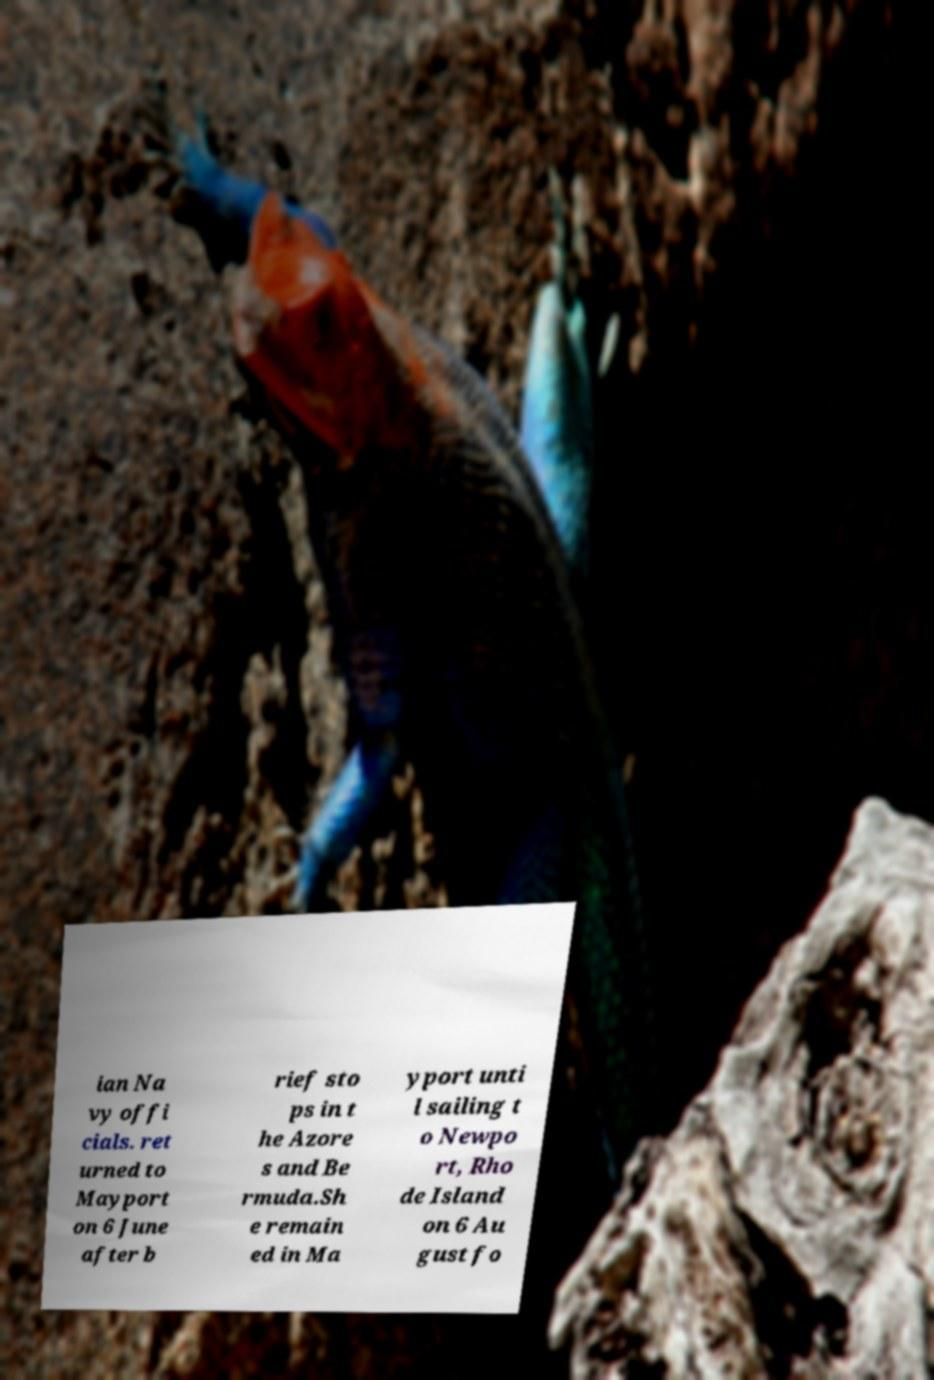Can you read and provide the text displayed in the image?This photo seems to have some interesting text. Can you extract and type it out for me? ian Na vy offi cials. ret urned to Mayport on 6 June after b rief sto ps in t he Azore s and Be rmuda.Sh e remain ed in Ma yport unti l sailing t o Newpo rt, Rho de Island on 6 Au gust fo 